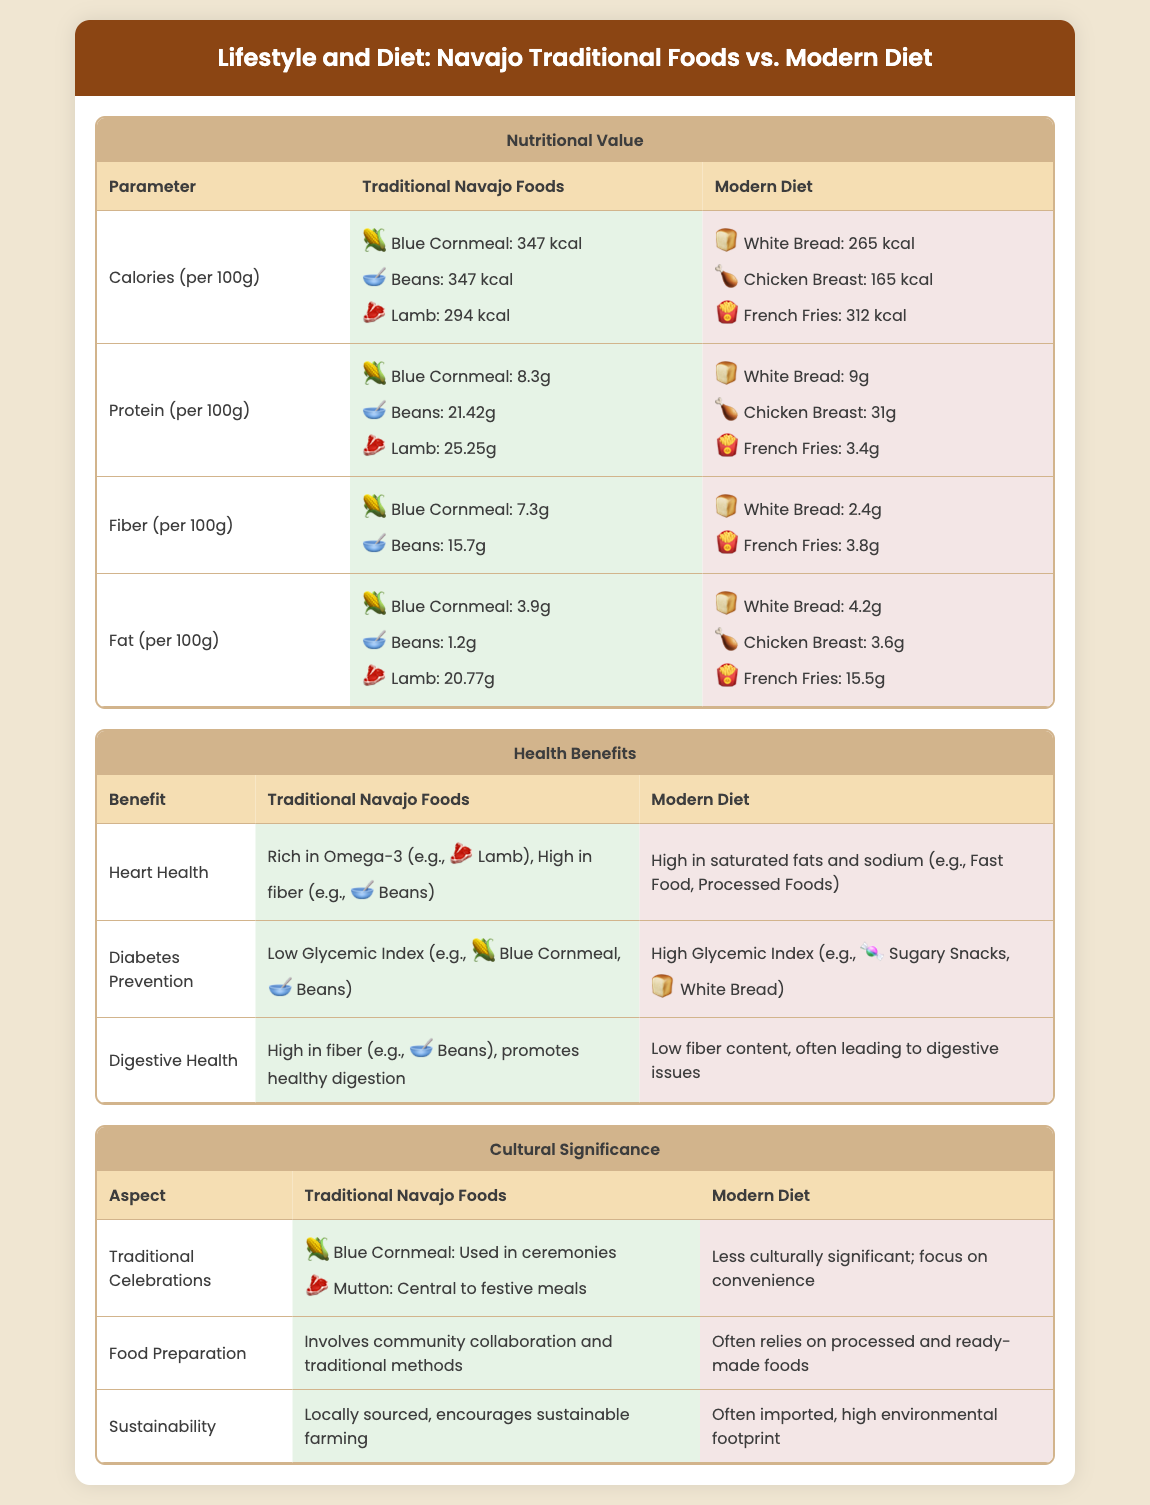What is the calorie content of blue cornmeal? The calorie content per 100g of blue cornmeal is 347 kcal as stated in the nutritional value section.
Answer: 347 kcal What is the protein content of beans? The protein content per 100g of beans is 21.42g, found in the nutritional value table.
Answer: 21.42g Which traditional food is noted for promoting heart health? Lamb is rich in omega-3 and considered beneficial for heart health in traditional Navajo foods.
Answer: Lamb What is the fiber content of white bread? The fiber content per 100g of white bread is 2.4g, as mentioned in the nutritional value section.
Answer: 2.4g How do traditional Navajo foods contribute to diabetes prevention? Traditional Navajo foods have a low glycemic index, specifically blue cornmeal and beans, which is mentioned under health benefits.
Answer: Low Glycemic Index What aspect compares traditional food preparation to modern diets? Traditional food preparation involves community collaboration and traditional methods, while modern diets rely on processed foods.
Answer: Community collaboration Which food has a higher fat content, lamb or chicken breast? Lamb has a higher fat content at 20.77g per 100g compared to chicken breast’s 3.6g, as shown in the nutritional value section.
Answer: Lamb What cultural role does blue cornmeal play? Blue cornmeal is used in ceremonies, highlighting its cultural significance in traditional celebrations.
Answer: Used in ceremonies 